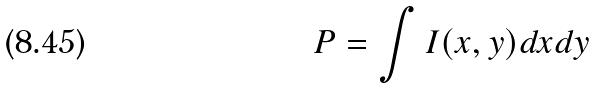<formula> <loc_0><loc_0><loc_500><loc_500>P = \int I ( x , y ) d x d y</formula> 